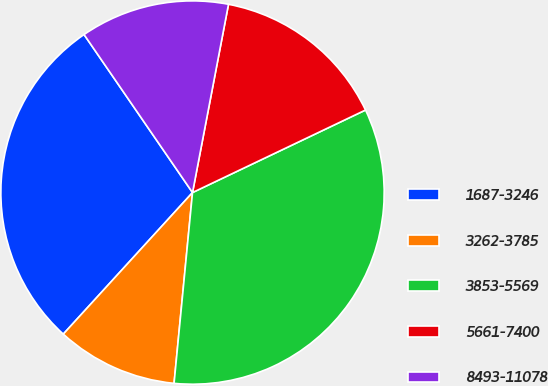<chart> <loc_0><loc_0><loc_500><loc_500><pie_chart><fcel>1687-3246<fcel>3262-3785<fcel>3853-5569<fcel>5661-7400<fcel>8493-11078<nl><fcel>28.65%<fcel>10.24%<fcel>33.62%<fcel>14.91%<fcel>12.58%<nl></chart> 